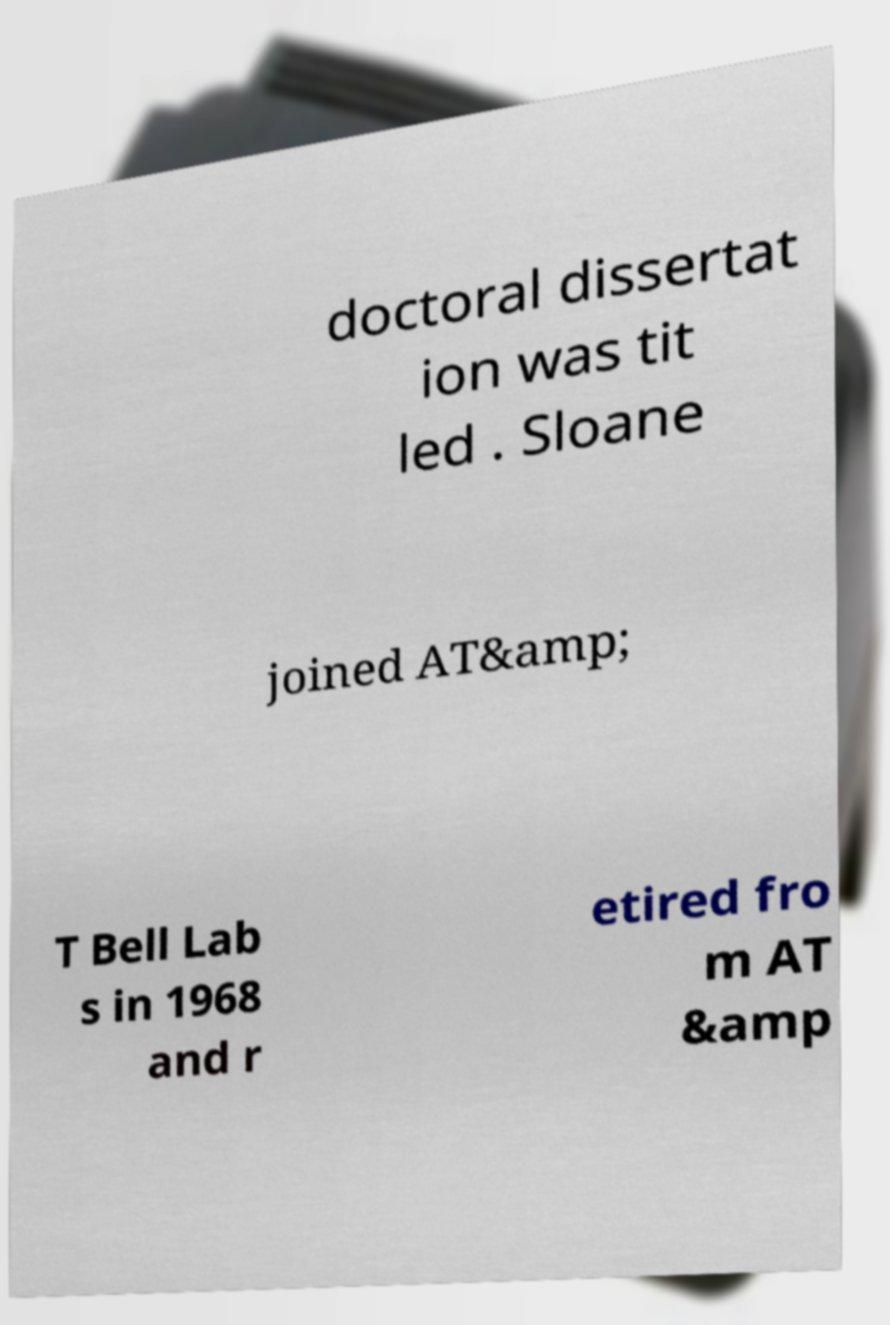Can you accurately transcribe the text from the provided image for me? doctoral dissertat ion was tit led . Sloane joined AT&amp; T Bell Lab s in 1968 and r etired fro m AT &amp 